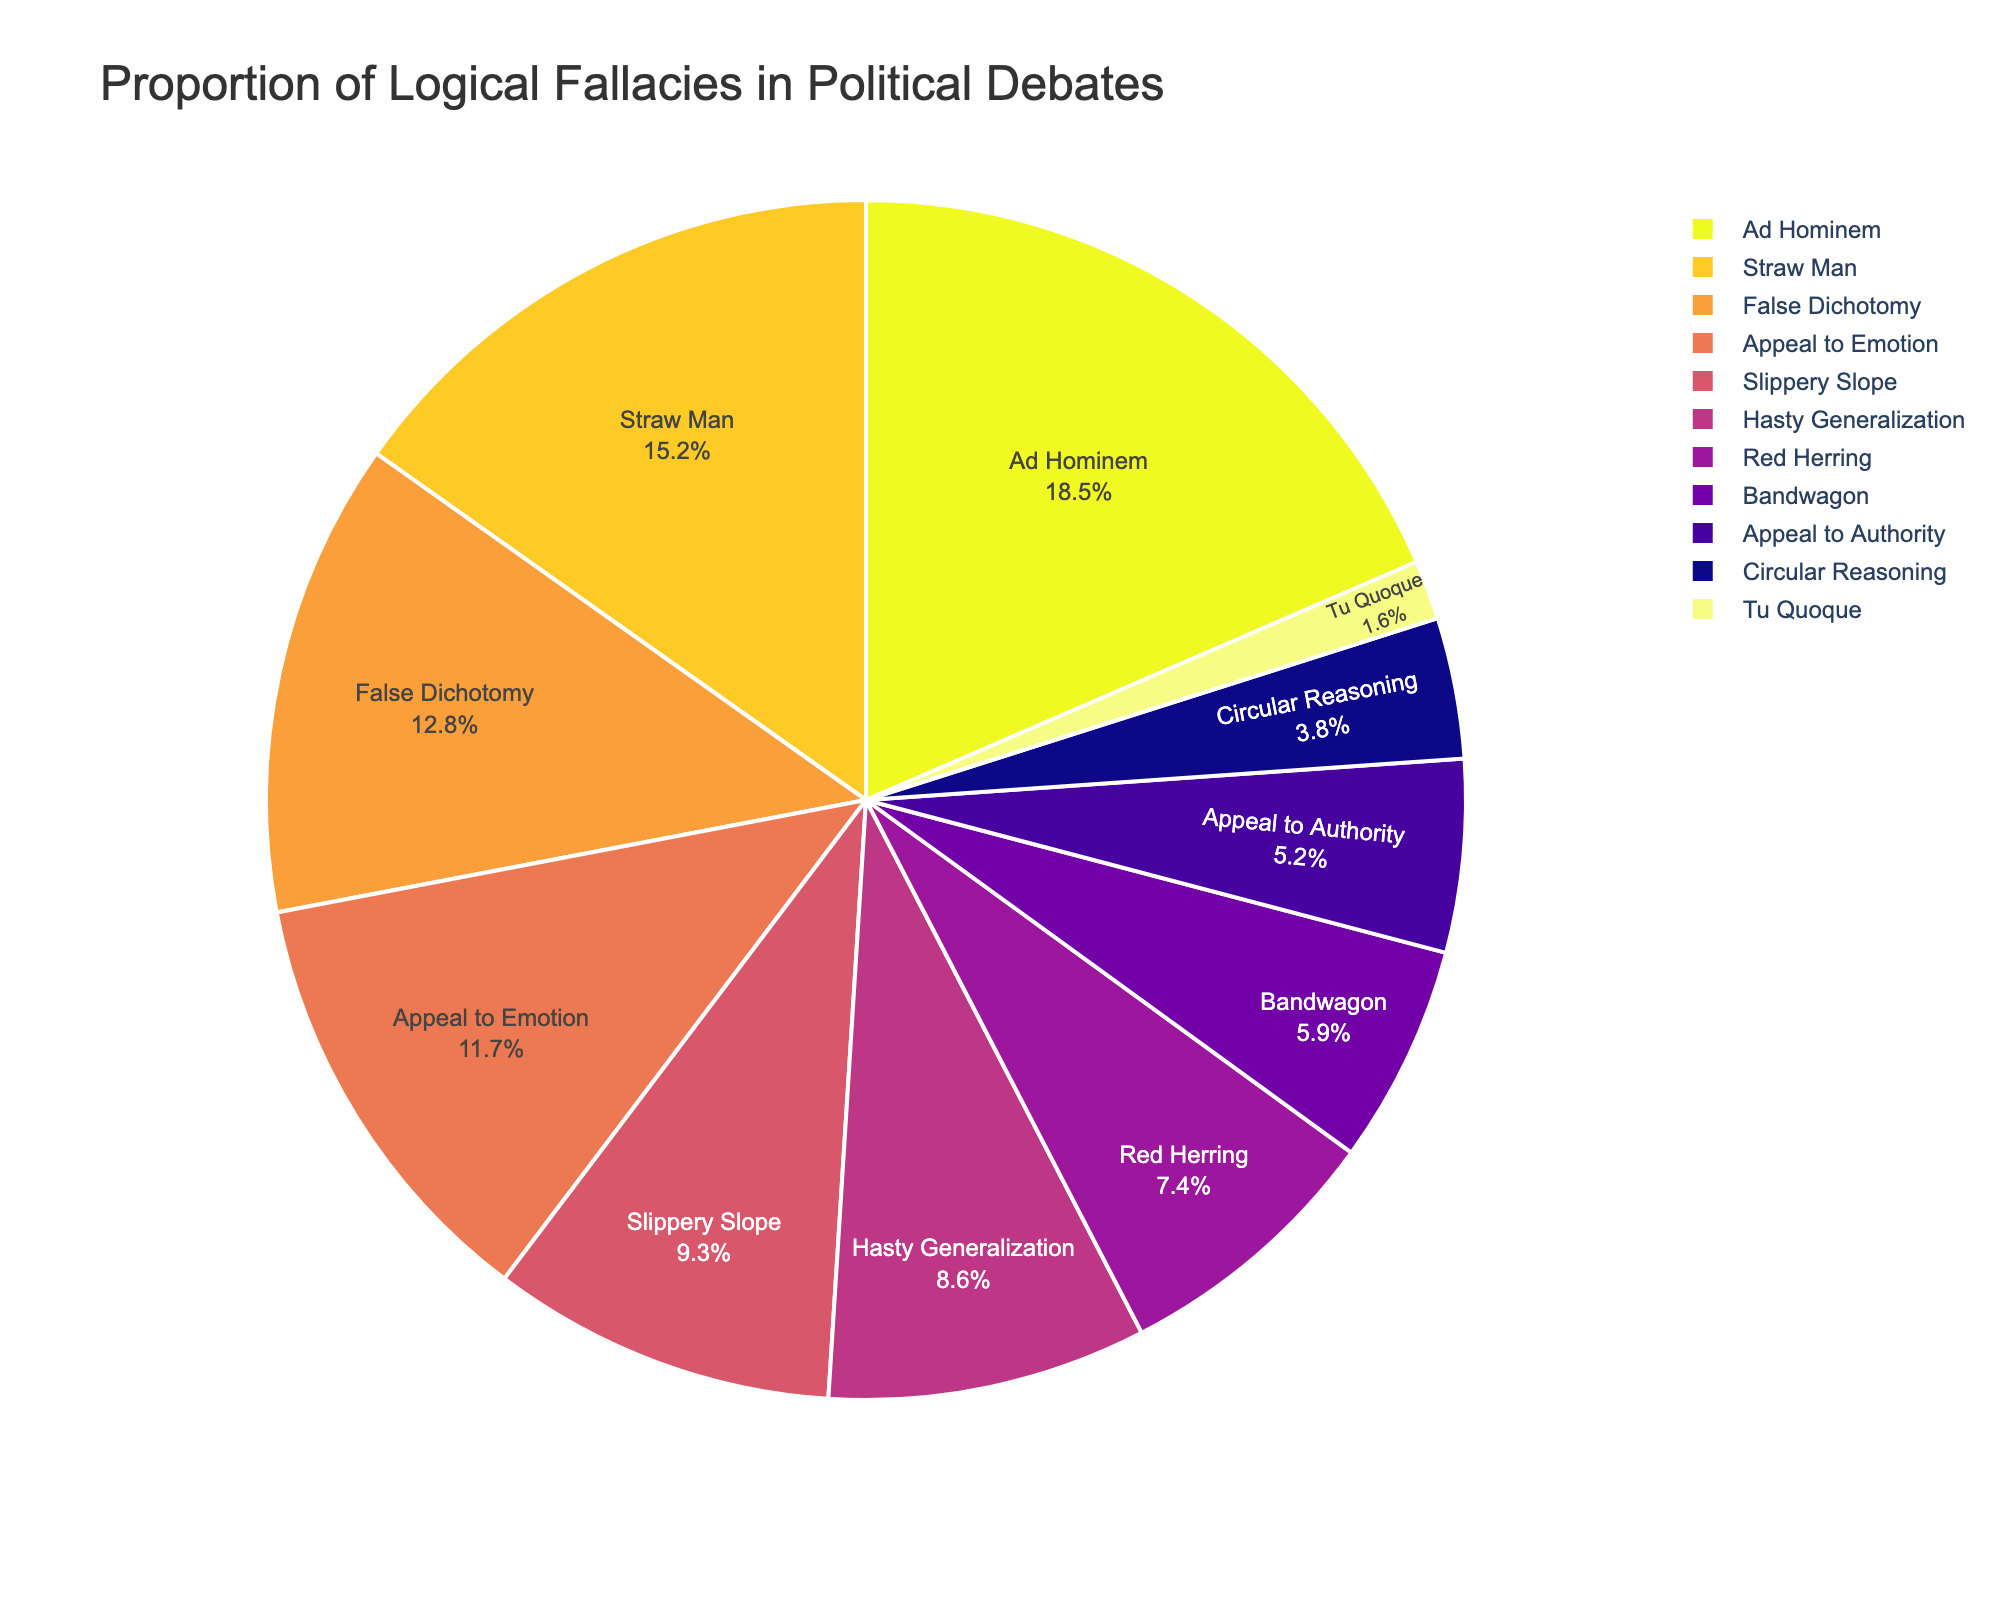What's the most common logical fallacy in political debates? By looking at the figure, we see that the largest slice of the pie chart is labeled "Ad Hominem". Therefore, the most common logical fallacy in political debates is Ad Hominem.
Answer: Ad Hominem Which logical fallacy appears the least frequently? The smallest slice of the pie chart is labeled "Tu Quoque", meaning it is the logical fallacy that appears the least frequently.
Answer: Tu Quoque How much greater is the percentage of Ad Hominem fallacies compared to Straw Man fallacies? The pie chart shows Ad Hominem at 18.5% and Straw Man at 15.2%. The difference is 18.5% - 15.2% = 3.3%.
Answer: 3.3% What's the combined percentage of False Dichotomy and Appeal to Emotion fallacies? From the pie chart, False Dichotomy is 12.8% and Appeal to Emotion is 11.7%. The combined percentage is 12.8% + 11.7% = 24.5%.
Answer: 24.5% Are the percentages of Slippery Slope and Hasty Generalization fallacies combined larger than Ad Hominem alone? Slippery Slope is 9.3% and Hasty Generalization is 8.6%. Their combined percentage is 9.3% + 8.6% = 17.9%, which is less than Ad Hominem at 18.5%.
Answer: No What is the average percentage of the three most common logical fallacies? The three most common fallacies are Ad Hominem (18.5%), Straw Man (15.2%), and False Dichotomy (12.8%). Their average is (18.5% + 15.2% + 12.8%) / 3 = 15.5%.
Answer: 15.5% Which logical fallacies together make up more than 50% of the total? Adding the percentages: Ad Hominem (18.5%) + Straw Man (15.2%) + False Dichotomy (12.8%) totals 46.5%, which is not enough. Including Appeal to Emotion (11.7%) totals 46.5% + 11.7% = 58.2%, which is greater than 50%.
Answer: Ad Hominem, Straw Man, False Dichotomy, and Appeal to Emotion What fraction of the total do Red Herring and Bandwagon fallacies represent? Red Herring is 7.4% and Bandwagon is 5.9%. Combined, they form 7.4% + 5.9% = 13.3%. As a fraction of 100%, this is 13.3/100 = 0.133 or approximately 13.3%.
Answer: 13.3% If the combined total percentage of Bandwagon and Appeal to Authority fallacies were divided equally, what would each's percentage be? Bandwagon is 5.9% and Appeal to Authority is 5.2%. Combined, they total 5.9% + 5.2% = 11.1%. When divided equally, each would be 11.1% / 2 = 5.55%.
Answer: 5.55% Between Hasty Generalization and False Dichotomy, which has a higher percentage? Comparing the two slices, False Dichotomy is 12.8% while Hasty Generalization is 8.6%. So, False Dichotomy has a higher percentage.
Answer: False Dichotomy 